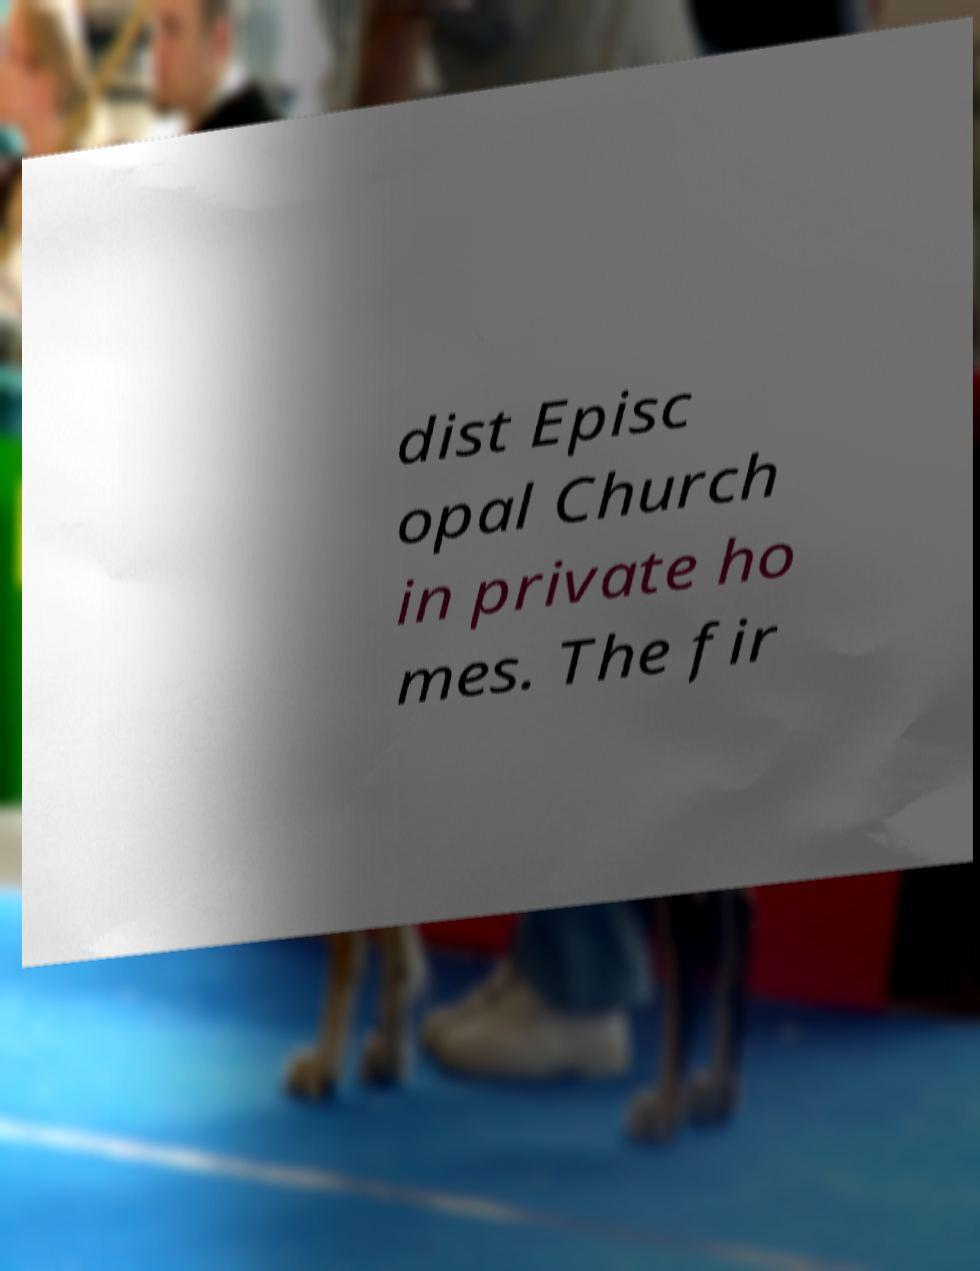I need the written content from this picture converted into text. Can you do that? dist Episc opal Church in private ho mes. The fir 